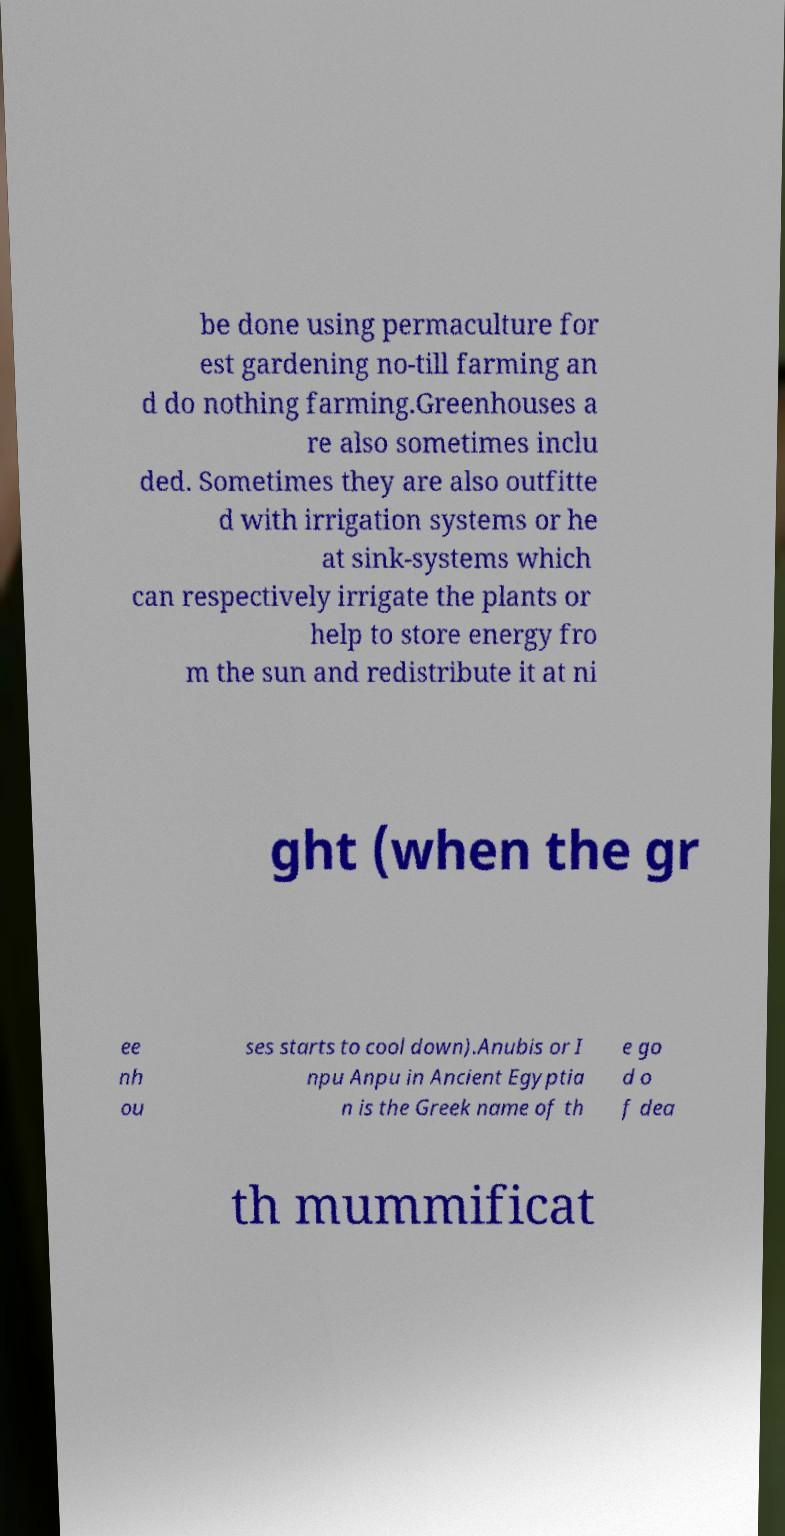Can you accurately transcribe the text from the provided image for me? be done using permaculture for est gardening no-till farming an d do nothing farming.Greenhouses a re also sometimes inclu ded. Sometimes they are also outfitte d with irrigation systems or he at sink-systems which can respectively irrigate the plants or help to store energy fro m the sun and redistribute it at ni ght (when the gr ee nh ou ses starts to cool down).Anubis or I npu Anpu in Ancient Egyptia n is the Greek name of th e go d o f dea th mummificat 